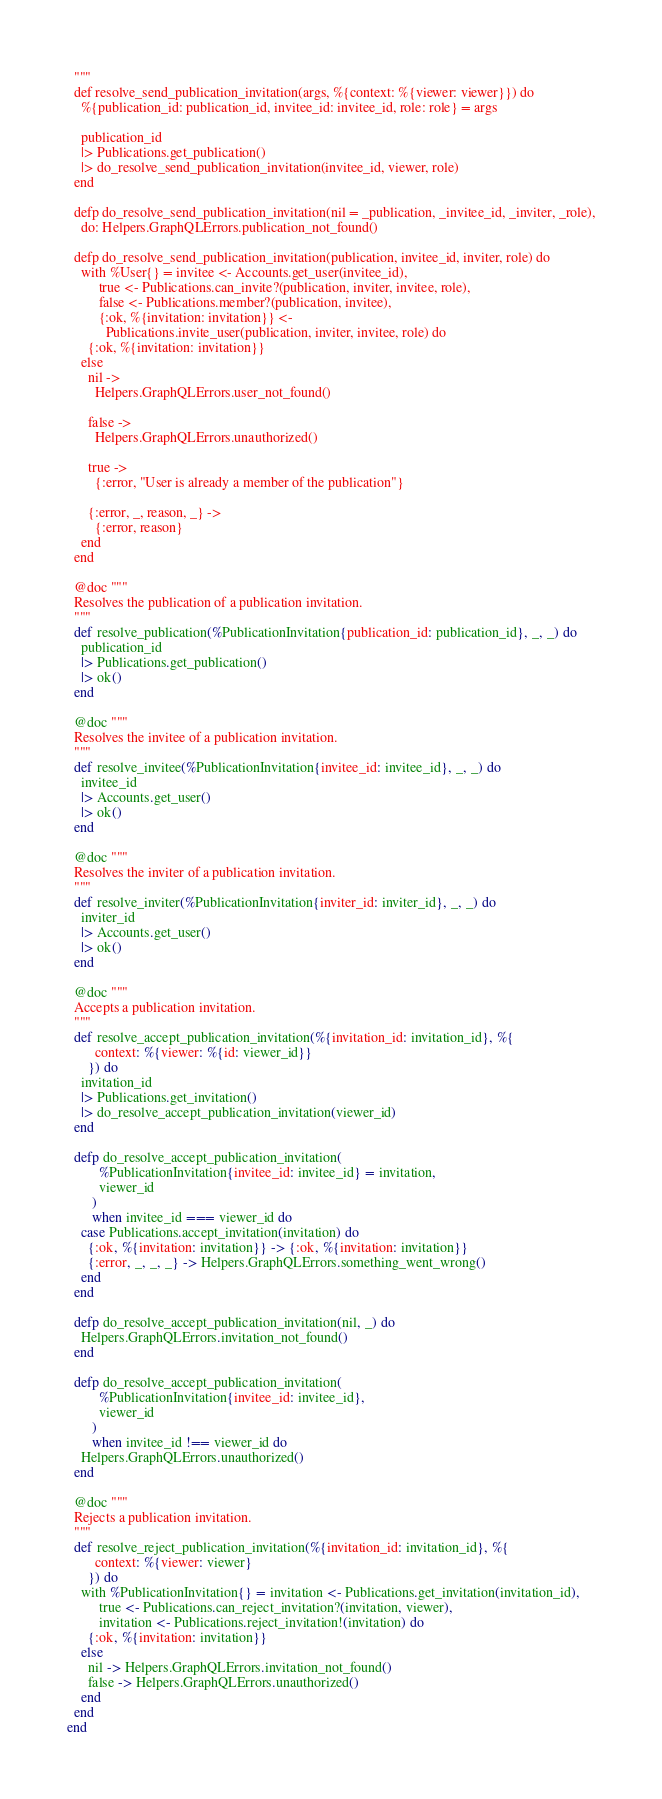<code> <loc_0><loc_0><loc_500><loc_500><_Elixir_>  """
  def resolve_send_publication_invitation(args, %{context: %{viewer: viewer}}) do
    %{publication_id: publication_id, invitee_id: invitee_id, role: role} = args

    publication_id
    |> Publications.get_publication()
    |> do_resolve_send_publication_invitation(invitee_id, viewer, role)
  end

  defp do_resolve_send_publication_invitation(nil = _publication, _invitee_id, _inviter, _role),
    do: Helpers.GraphQLErrors.publication_not_found()

  defp do_resolve_send_publication_invitation(publication, invitee_id, inviter, role) do
    with %User{} = invitee <- Accounts.get_user(invitee_id),
         true <- Publications.can_invite?(publication, inviter, invitee, role),
         false <- Publications.member?(publication, invitee),
         {:ok, %{invitation: invitation}} <-
           Publications.invite_user(publication, inviter, invitee, role) do
      {:ok, %{invitation: invitation}}
    else
      nil ->
        Helpers.GraphQLErrors.user_not_found()

      false ->
        Helpers.GraphQLErrors.unauthorized()

      true ->
        {:error, "User is already a member of the publication"}

      {:error, _, reason, _} ->
        {:error, reason}
    end
  end

  @doc """
  Resolves the publication of a publication invitation.
  """
  def resolve_publication(%PublicationInvitation{publication_id: publication_id}, _, _) do
    publication_id
    |> Publications.get_publication()
    |> ok()
  end

  @doc """
  Resolves the invitee of a publication invitation.
  """
  def resolve_invitee(%PublicationInvitation{invitee_id: invitee_id}, _, _) do
    invitee_id
    |> Accounts.get_user()
    |> ok()
  end

  @doc """
  Resolves the inviter of a publication invitation.
  """
  def resolve_inviter(%PublicationInvitation{inviter_id: inviter_id}, _, _) do
    inviter_id
    |> Accounts.get_user()
    |> ok()
  end

  @doc """
  Accepts a publication invitation.
  """
  def resolve_accept_publication_invitation(%{invitation_id: invitation_id}, %{
        context: %{viewer: %{id: viewer_id}}
      }) do
    invitation_id
    |> Publications.get_invitation()
    |> do_resolve_accept_publication_invitation(viewer_id)
  end

  defp do_resolve_accept_publication_invitation(
         %PublicationInvitation{invitee_id: invitee_id} = invitation,
         viewer_id
       )
       when invitee_id === viewer_id do
    case Publications.accept_invitation(invitation) do
      {:ok, %{invitation: invitation}} -> {:ok, %{invitation: invitation}}
      {:error, _, _, _} -> Helpers.GraphQLErrors.something_went_wrong()
    end
  end

  defp do_resolve_accept_publication_invitation(nil, _) do
    Helpers.GraphQLErrors.invitation_not_found()
  end

  defp do_resolve_accept_publication_invitation(
         %PublicationInvitation{invitee_id: invitee_id},
         viewer_id
       )
       when invitee_id !== viewer_id do
    Helpers.GraphQLErrors.unauthorized()
  end

  @doc """
  Rejects a publication invitation.
  """
  def resolve_reject_publication_invitation(%{invitation_id: invitation_id}, %{
        context: %{viewer: viewer}
      }) do
    with %PublicationInvitation{} = invitation <- Publications.get_invitation(invitation_id),
         true <- Publications.can_reject_invitation?(invitation, viewer),
         invitation <- Publications.reject_invitation!(invitation) do
      {:ok, %{invitation: invitation}}
    else
      nil -> Helpers.GraphQLErrors.invitation_not_found()
      false -> Helpers.GraphQLErrors.unauthorized()
    end
  end
end
</code> 